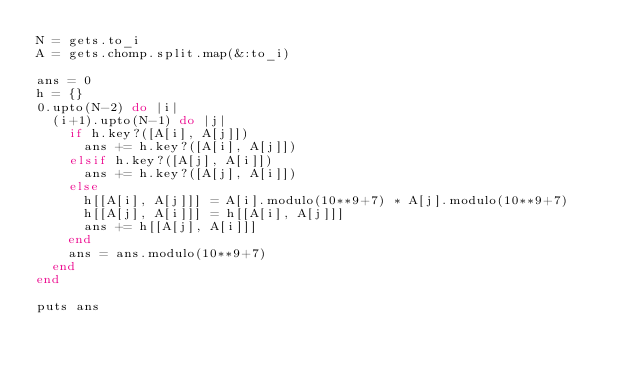<code> <loc_0><loc_0><loc_500><loc_500><_Ruby_>N = gets.to_i
A = gets.chomp.split.map(&:to_i)

ans = 0
h = {}
0.upto(N-2) do |i|
  (i+1).upto(N-1) do |j|
    if h.key?([A[i], A[j]])
      ans += h.key?([A[i], A[j]])
    elsif h.key?([A[j], A[i]])
      ans += h.key?([A[j], A[i]])
    else
      h[[A[i], A[j]]] = A[i].modulo(10**9+7) * A[j].modulo(10**9+7)
      h[[A[j], A[i]]] = h[[A[i], A[j]]]
      ans += h[[A[j], A[i]]]
    end
    ans = ans.modulo(10**9+7)
  end
end

puts ans</code> 